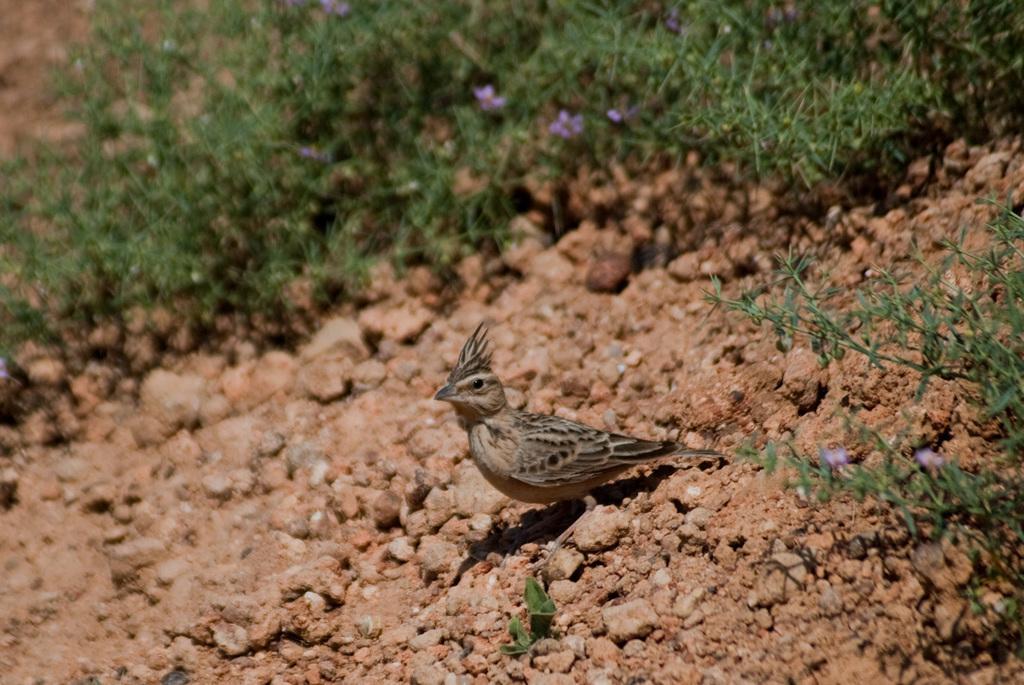Describe this image in one or two sentences. In this image we can see a bird. There are few plants in the image. There are few flowers to the plants. 